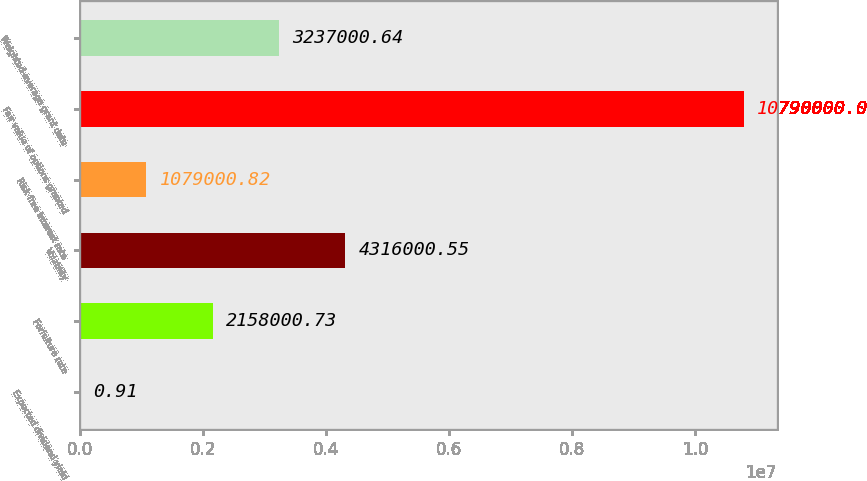Convert chart to OTSL. <chart><loc_0><loc_0><loc_500><loc_500><bar_chart><fcel>Expected dividend yield<fcel>Forfeiture rate<fcel>Volatility<fcel>Risk free interest rate<fcel>Fair value of options granted<fcel>Weighted-average grant date<nl><fcel>0.91<fcel>2.158e+06<fcel>4.316e+06<fcel>1.079e+06<fcel>1.079e+07<fcel>3.237e+06<nl></chart> 